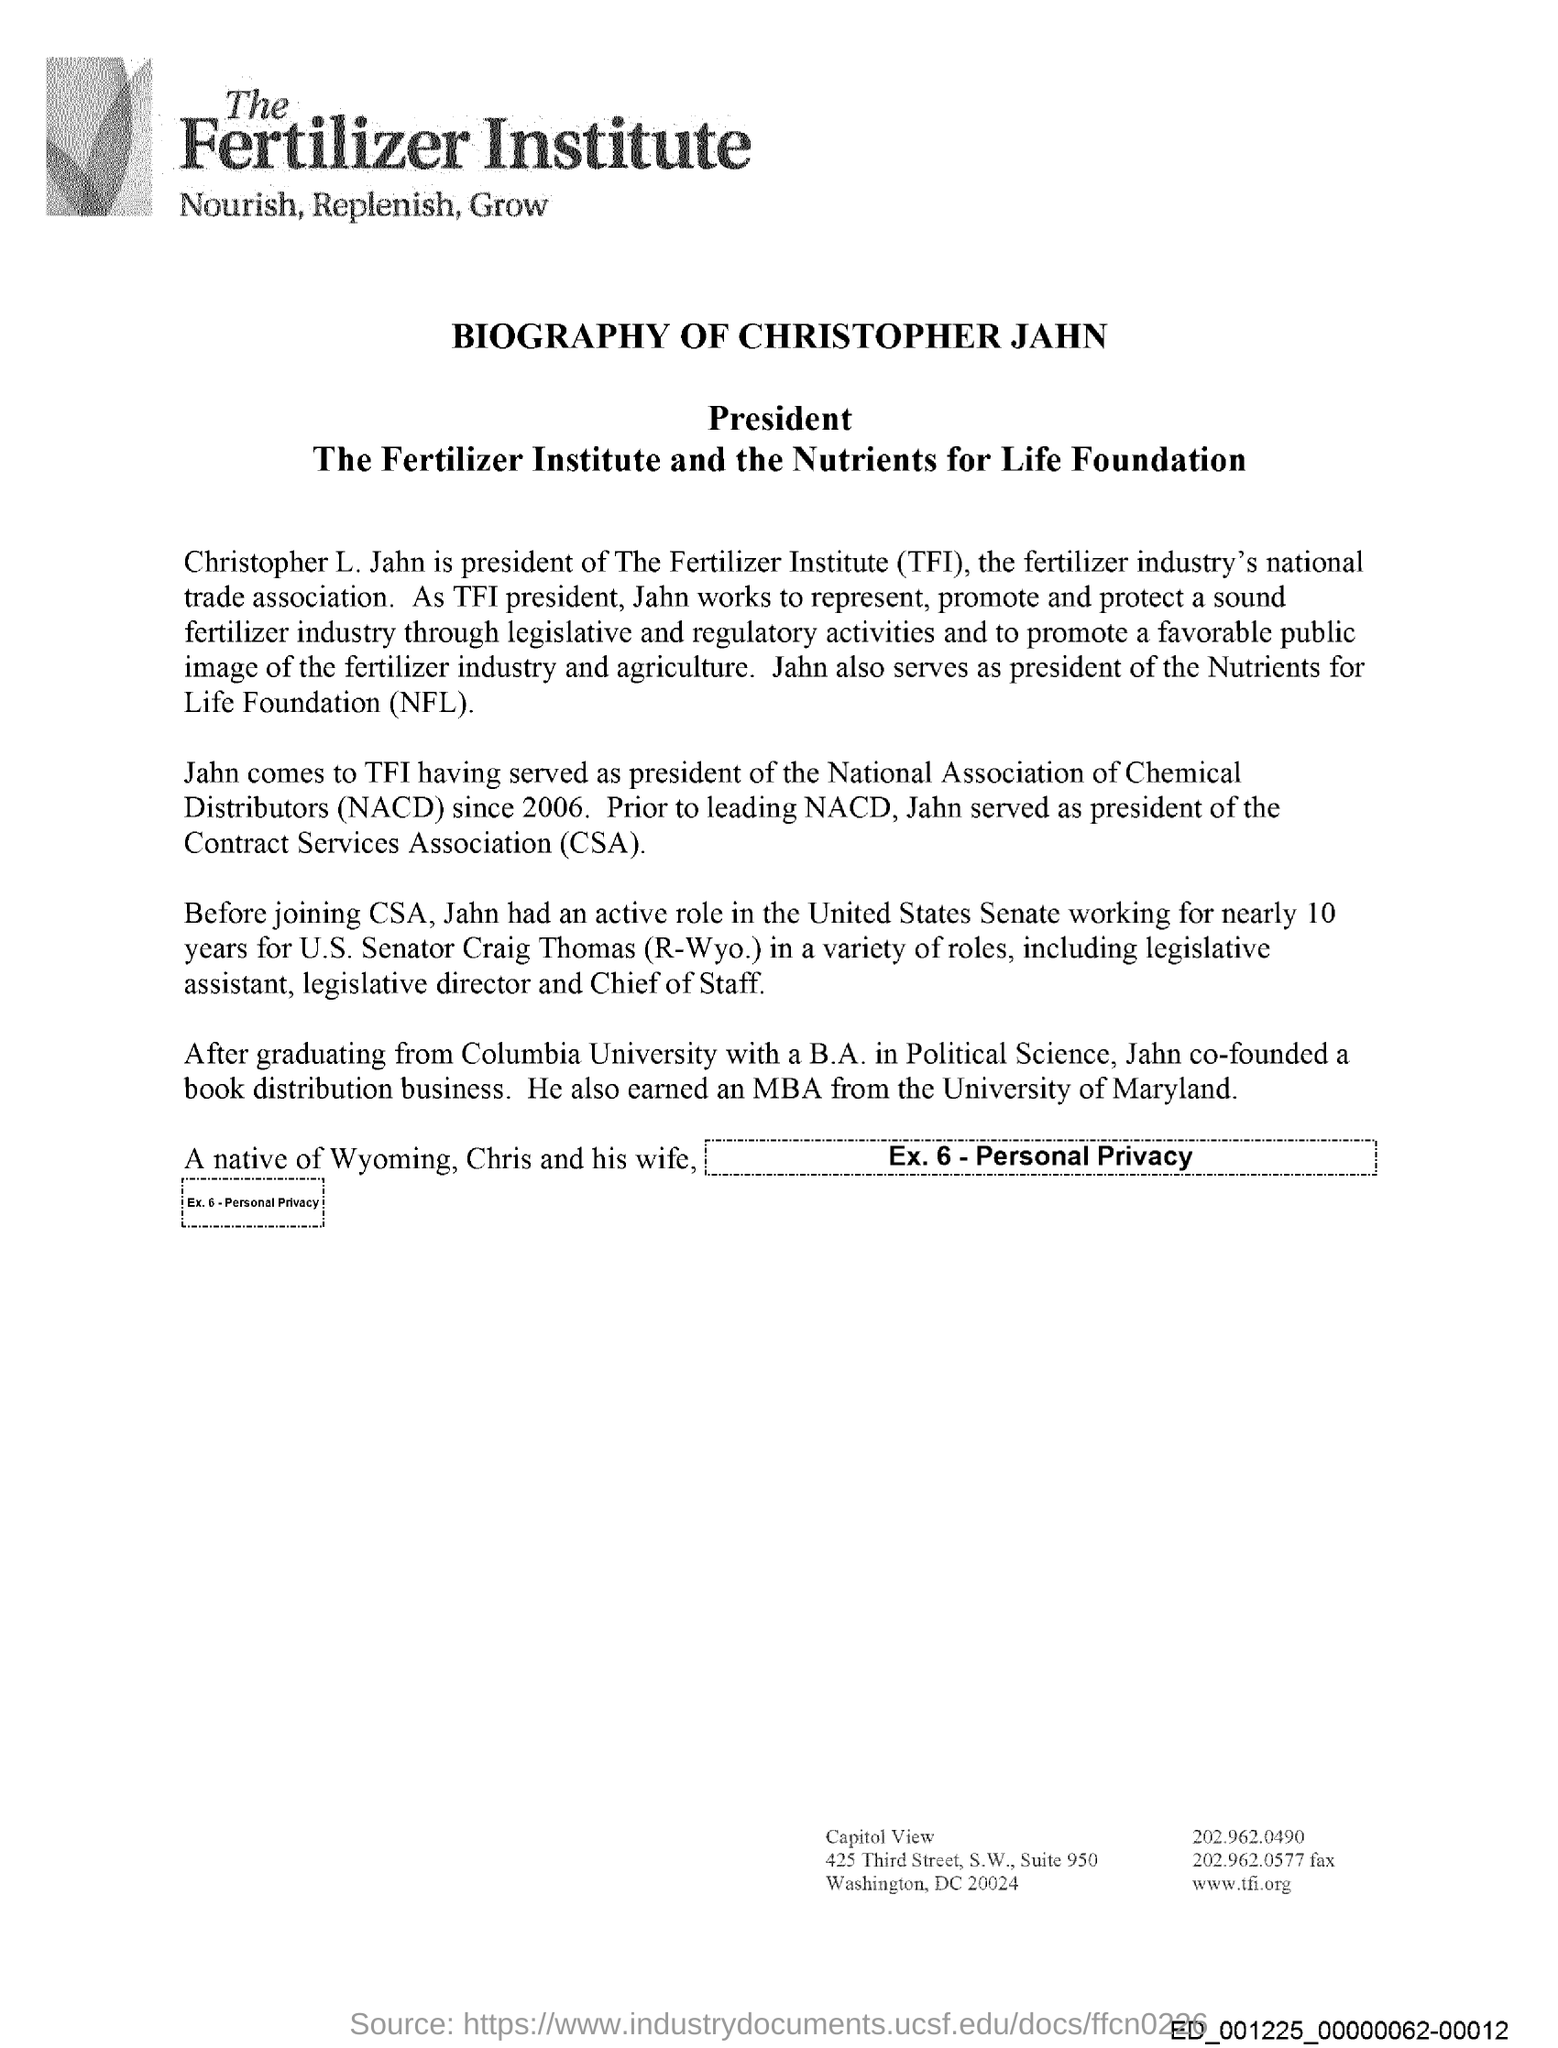Whose biography is this?
Ensure brevity in your answer.  Christopher Jahn. What is the full form of TFI?
Your answer should be compact. The Fertilizer Institute. For how many years did Christopher Jahn work for U.S. Senator Craig Thomas?
Ensure brevity in your answer.  Nearly 10 years. What is the full form CSA?
Make the answer very short. Contract Services Association. 